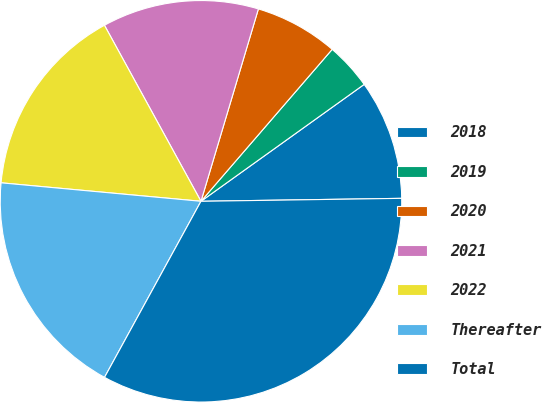<chart> <loc_0><loc_0><loc_500><loc_500><pie_chart><fcel>2018<fcel>2019<fcel>2020<fcel>2021<fcel>2022<fcel>Thereafter<fcel>Total<nl><fcel>9.66%<fcel>3.77%<fcel>6.72%<fcel>12.6%<fcel>15.55%<fcel>18.49%<fcel>33.21%<nl></chart> 